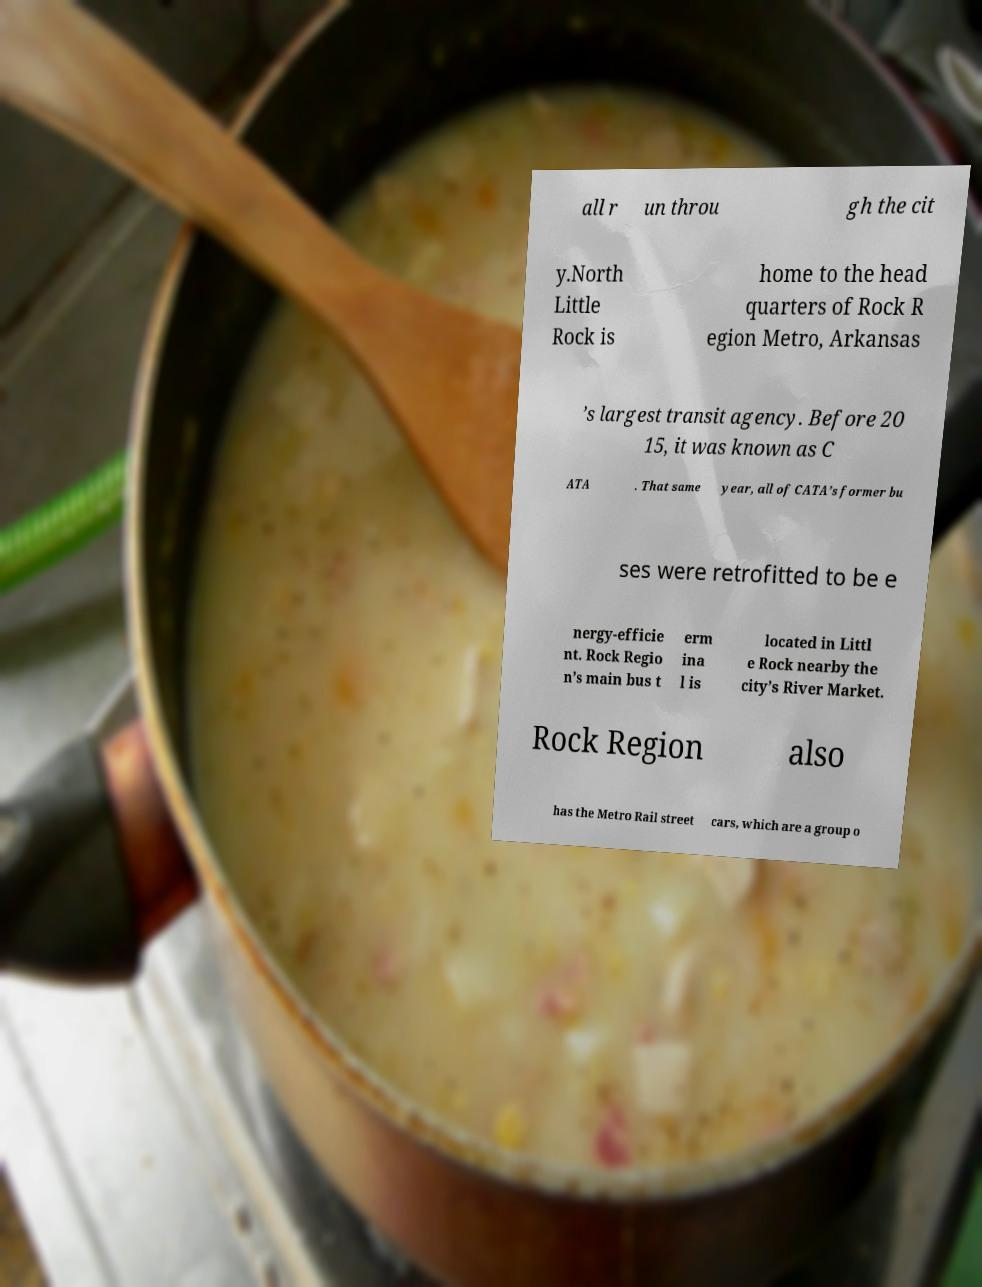What messages or text are displayed in this image? I need them in a readable, typed format. all r un throu gh the cit y.North Little Rock is home to the head quarters of Rock R egion Metro, Arkansas ’s largest transit agency. Before 20 15, it was known as C ATA . That same year, all of CATA’s former bu ses were retrofitted to be e nergy-efficie nt. Rock Regio n’s main bus t erm ina l is located in Littl e Rock nearby the city’s River Market. Rock Region also has the Metro Rail street cars, which are a group o 